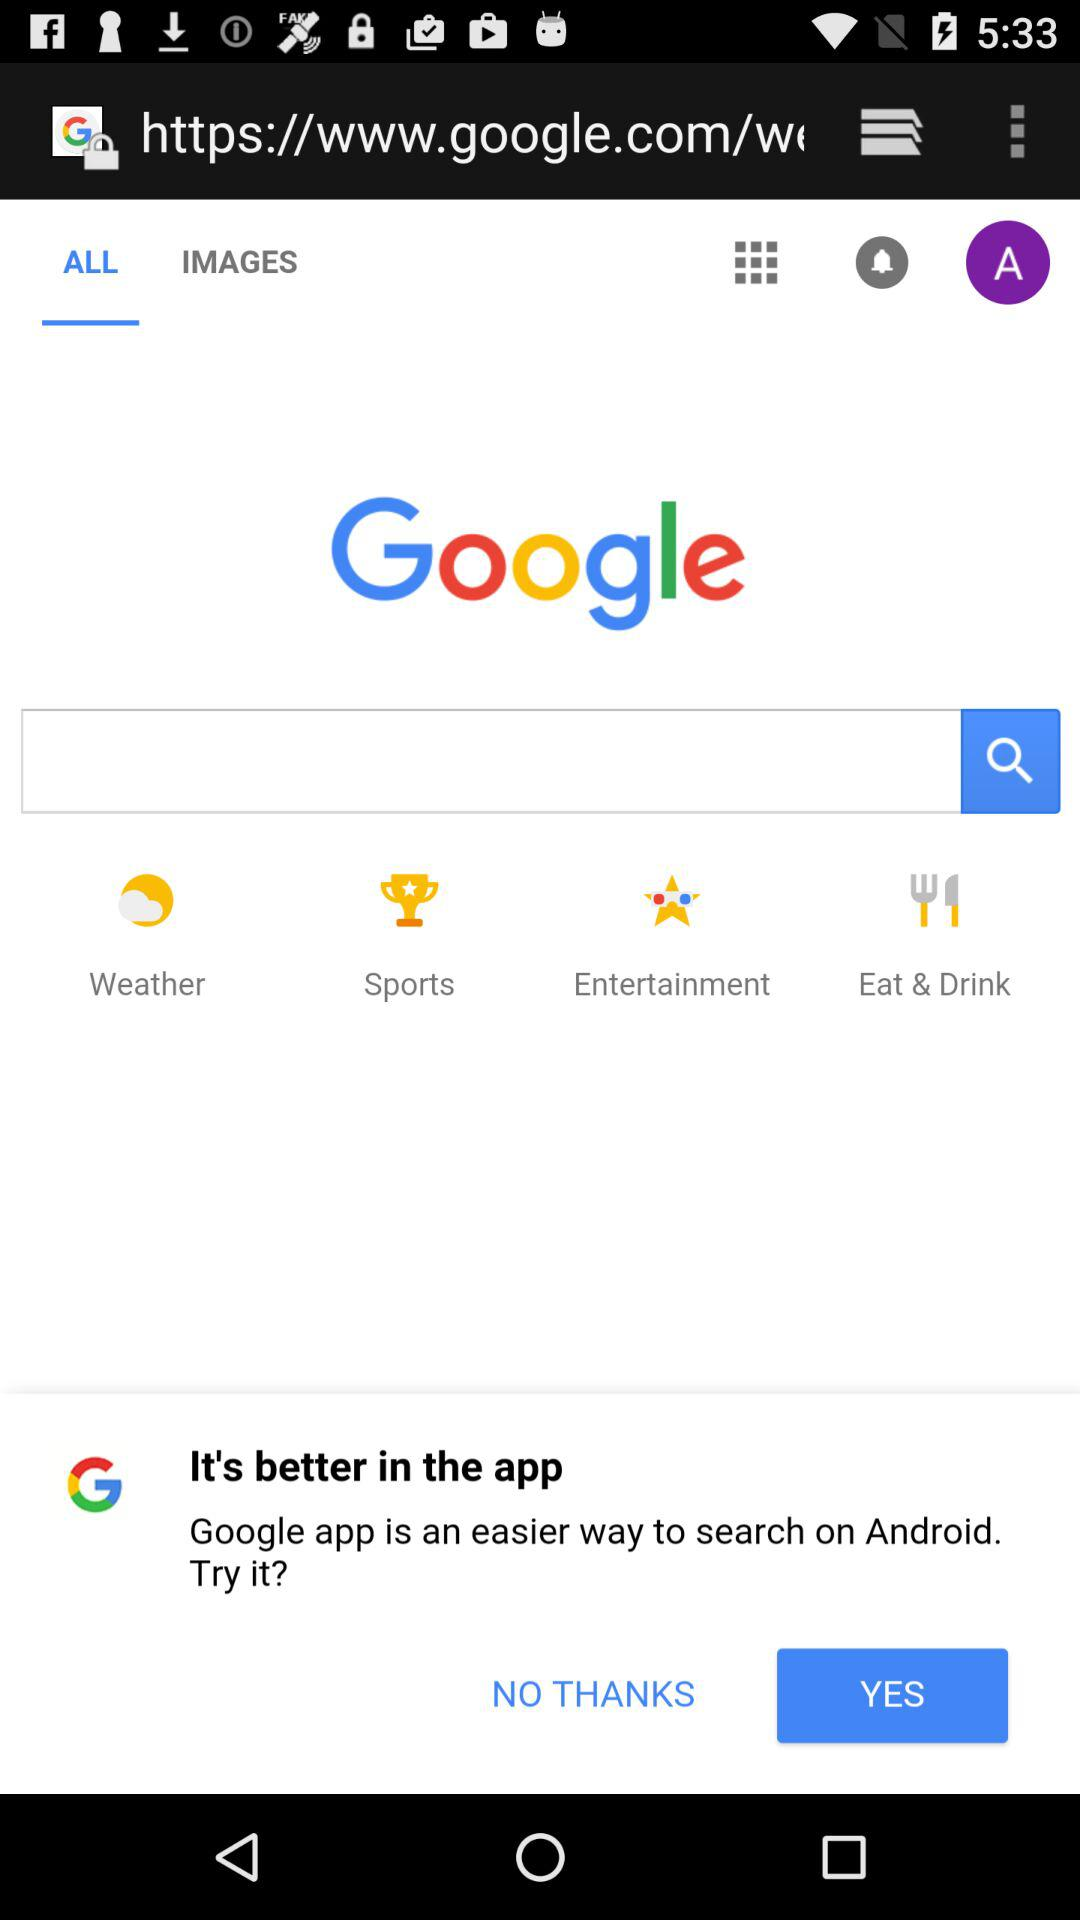Which tab am I using? You are using "ALL" tab. 